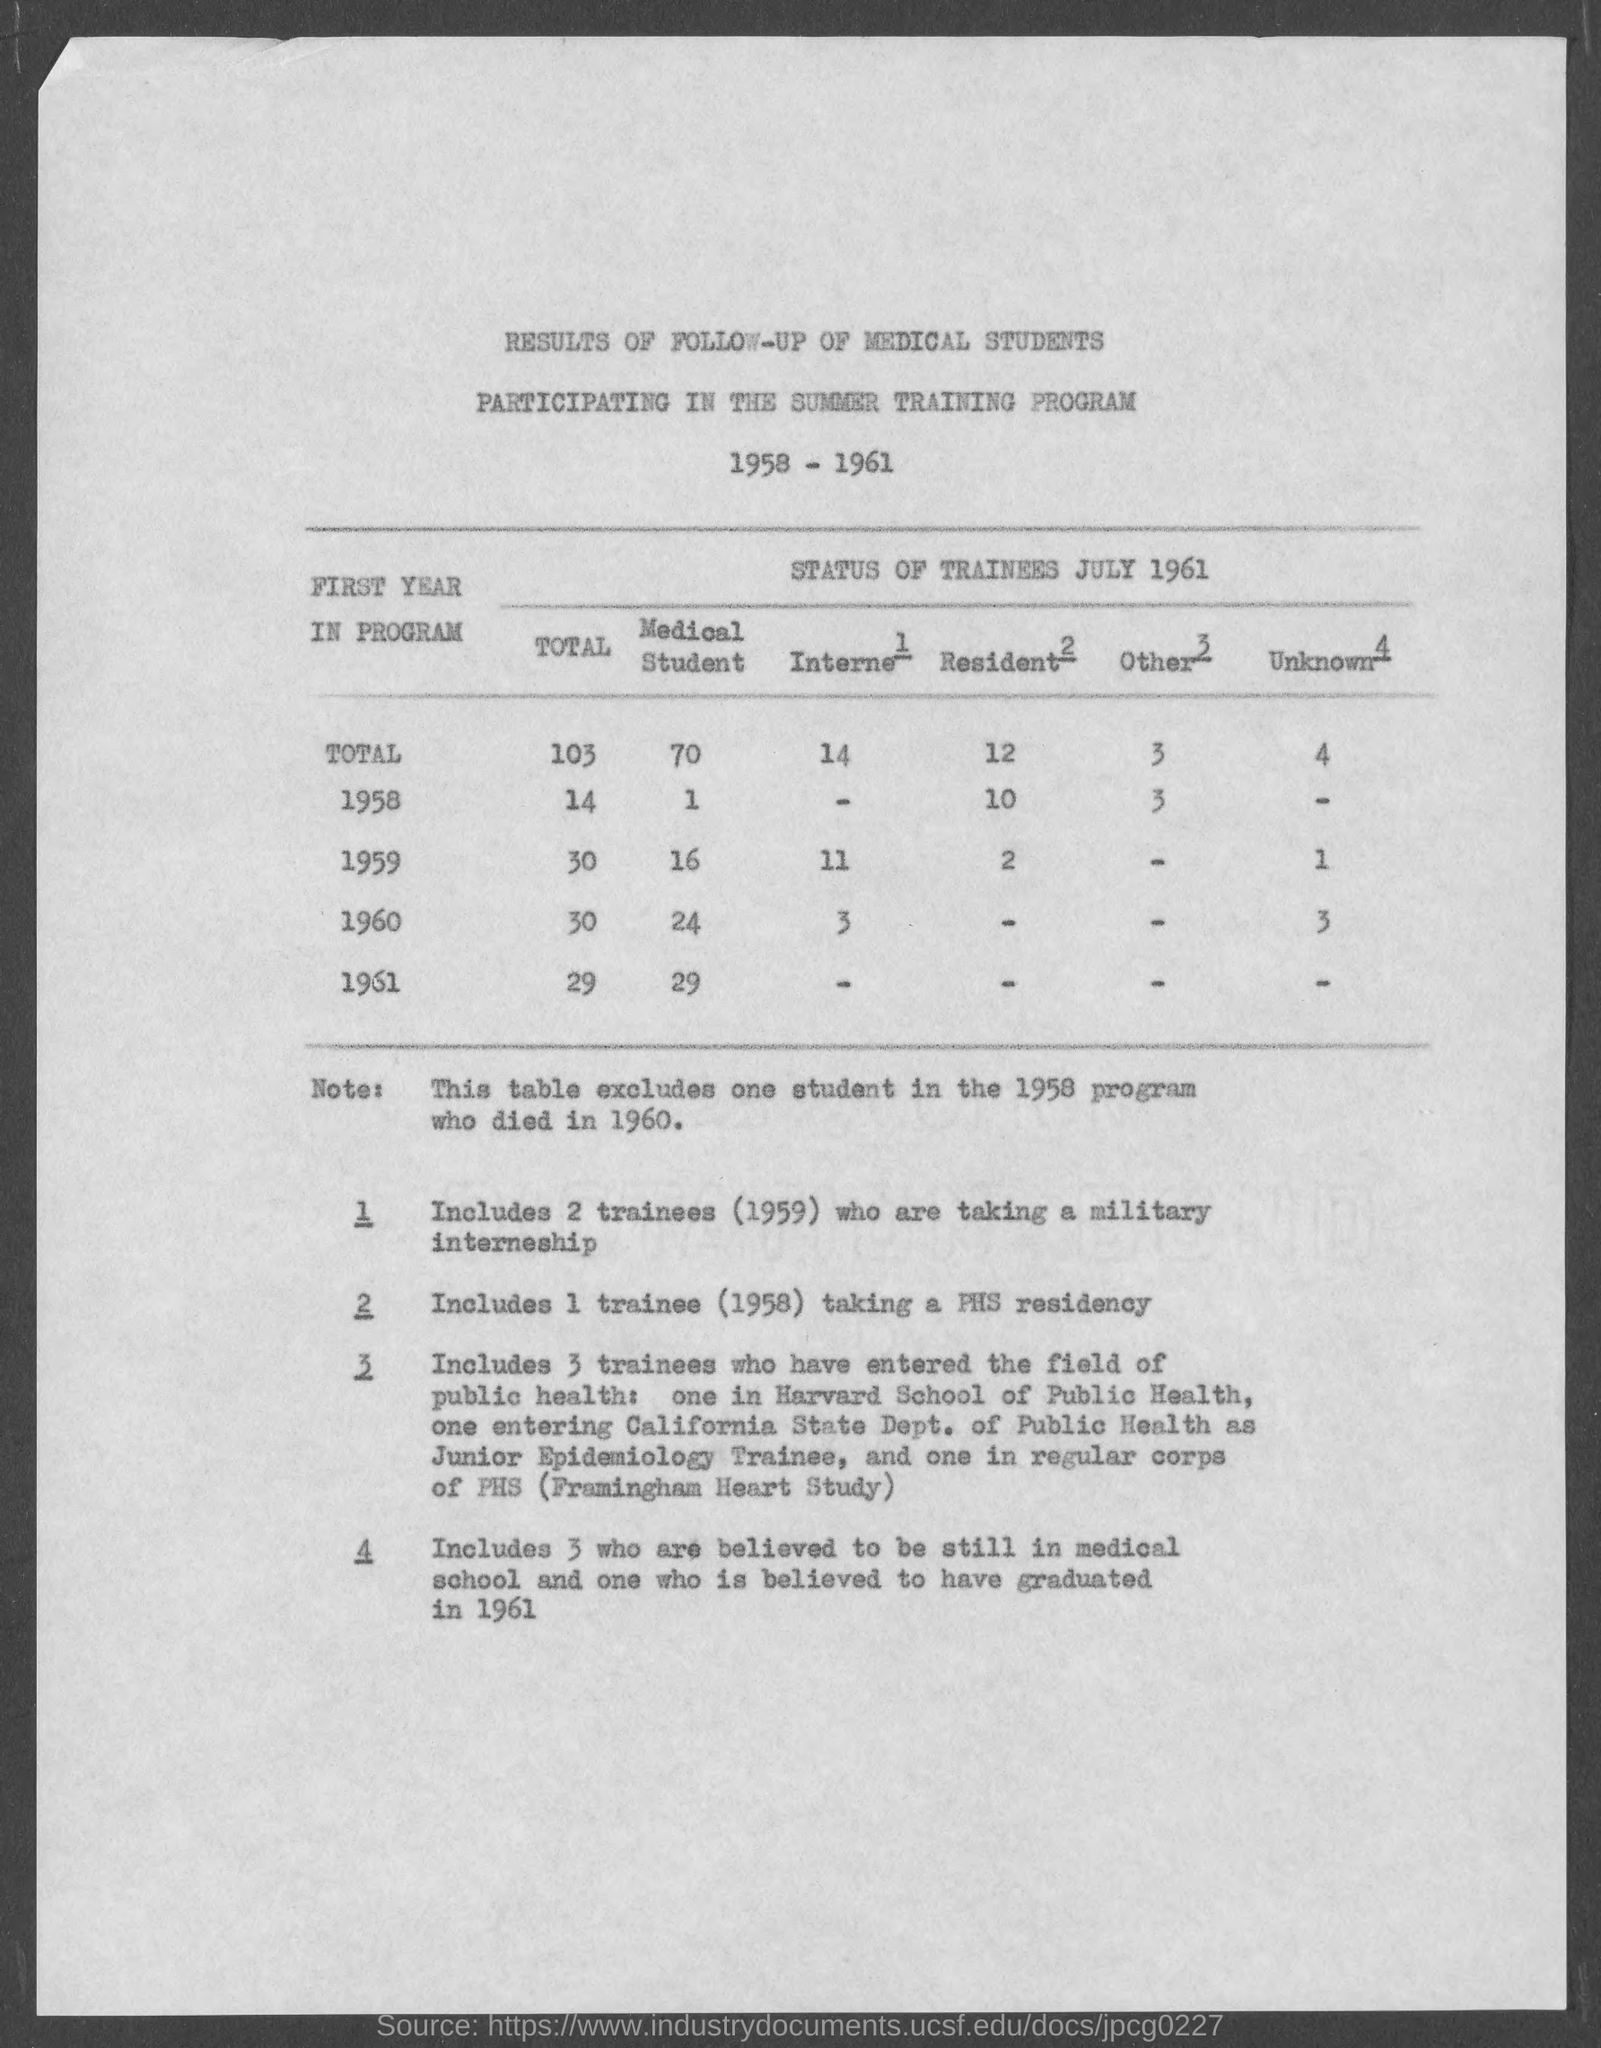What are the number of Medical Students for 1958?
Make the answer very short. 1. What are the number of Medical Students for 1959?
Your answer should be very brief. 16. What are the number of Medical Students for 1960?
Provide a succinct answer. 24. What are the number of Medical Students for 1961?
Your answer should be compact. 29. What are the Total  for Medical students?
Give a very brief answer. 70. What are the number of Interne for 1959?
Keep it short and to the point. 11. What are the number of Interne for 1960?
Ensure brevity in your answer.  3. What are the Total for Interne?
Give a very brief answer. 14. What are the number of Resident for 1958?
Ensure brevity in your answer.  10. What are the number of Resident for 1959?
Give a very brief answer. 2. 